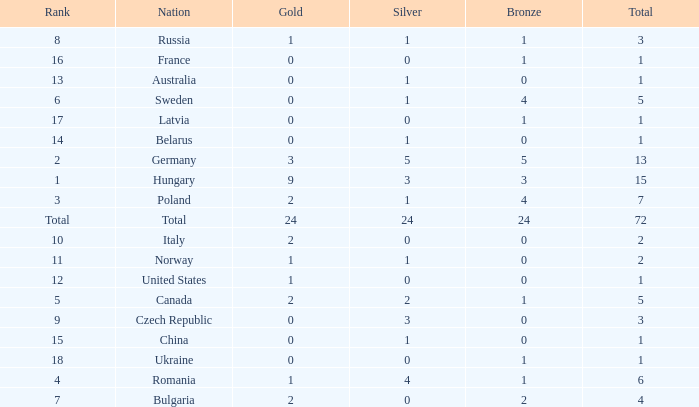What average total has 0 as the gold, with 6 as the rank? 5.0. 